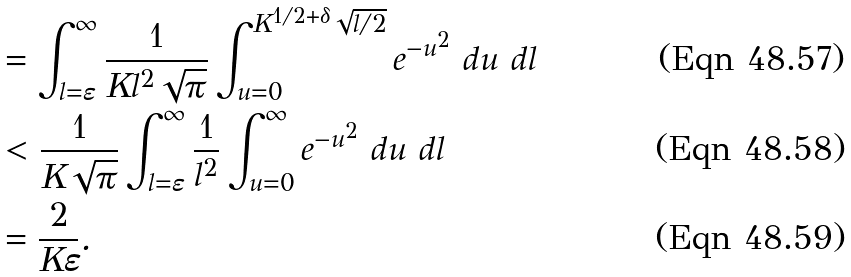Convert formula to latex. <formula><loc_0><loc_0><loc_500><loc_500>& = \int _ { l = \varepsilon } ^ { \infty } \frac { 1 } { K l ^ { 2 } \sqrt { \pi } } \int _ { u = 0 } ^ { K ^ { 1 / 2 + \delta } \sqrt { l / 2 } } e ^ { - u ^ { 2 } } \ d u \ d l \\ & < \frac { 1 } { K \sqrt { \pi } } \int _ { l = \varepsilon } ^ { \infty } \frac { 1 } { l ^ { 2 } } \int _ { u = 0 } ^ { \infty } e ^ { - u ^ { 2 } } \ d u \ d l \\ & = \frac { 2 } { K \varepsilon } .</formula> 